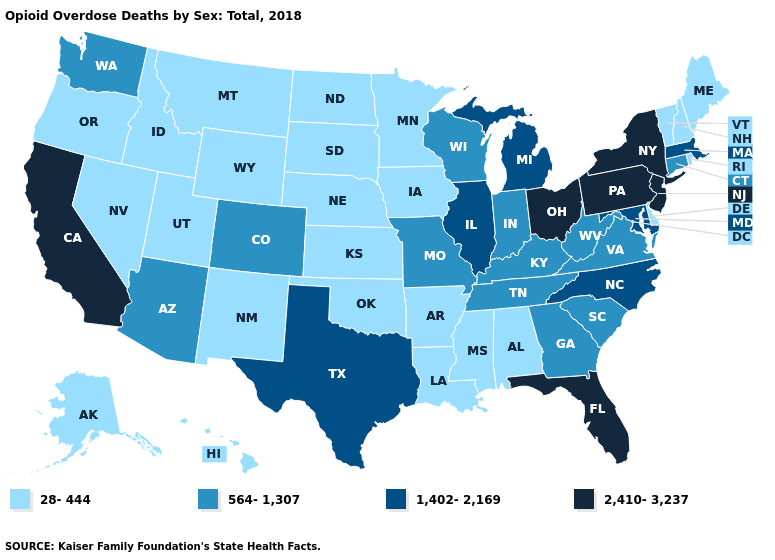Which states have the lowest value in the MidWest?
Concise answer only. Iowa, Kansas, Minnesota, Nebraska, North Dakota, South Dakota. Which states have the lowest value in the South?
Concise answer only. Alabama, Arkansas, Delaware, Louisiana, Mississippi, Oklahoma. What is the value of Rhode Island?
Be succinct. 28-444. How many symbols are there in the legend?
Keep it brief. 4. Name the states that have a value in the range 2,410-3,237?
Give a very brief answer. California, Florida, New Jersey, New York, Ohio, Pennsylvania. Does Minnesota have a lower value than Georgia?
Answer briefly. Yes. Name the states that have a value in the range 564-1,307?
Keep it brief. Arizona, Colorado, Connecticut, Georgia, Indiana, Kentucky, Missouri, South Carolina, Tennessee, Virginia, Washington, West Virginia, Wisconsin. Name the states that have a value in the range 564-1,307?
Write a very short answer. Arizona, Colorado, Connecticut, Georgia, Indiana, Kentucky, Missouri, South Carolina, Tennessee, Virginia, Washington, West Virginia, Wisconsin. Which states have the highest value in the USA?
Short answer required. California, Florida, New Jersey, New York, Ohio, Pennsylvania. Does the map have missing data?
Keep it brief. No. What is the value of Louisiana?
Write a very short answer. 28-444. Does the first symbol in the legend represent the smallest category?
Quick response, please. Yes. What is the highest value in the MidWest ?
Answer briefly. 2,410-3,237. What is the value of Kentucky?
Write a very short answer. 564-1,307. Does Nevada have the lowest value in the USA?
Write a very short answer. Yes. 